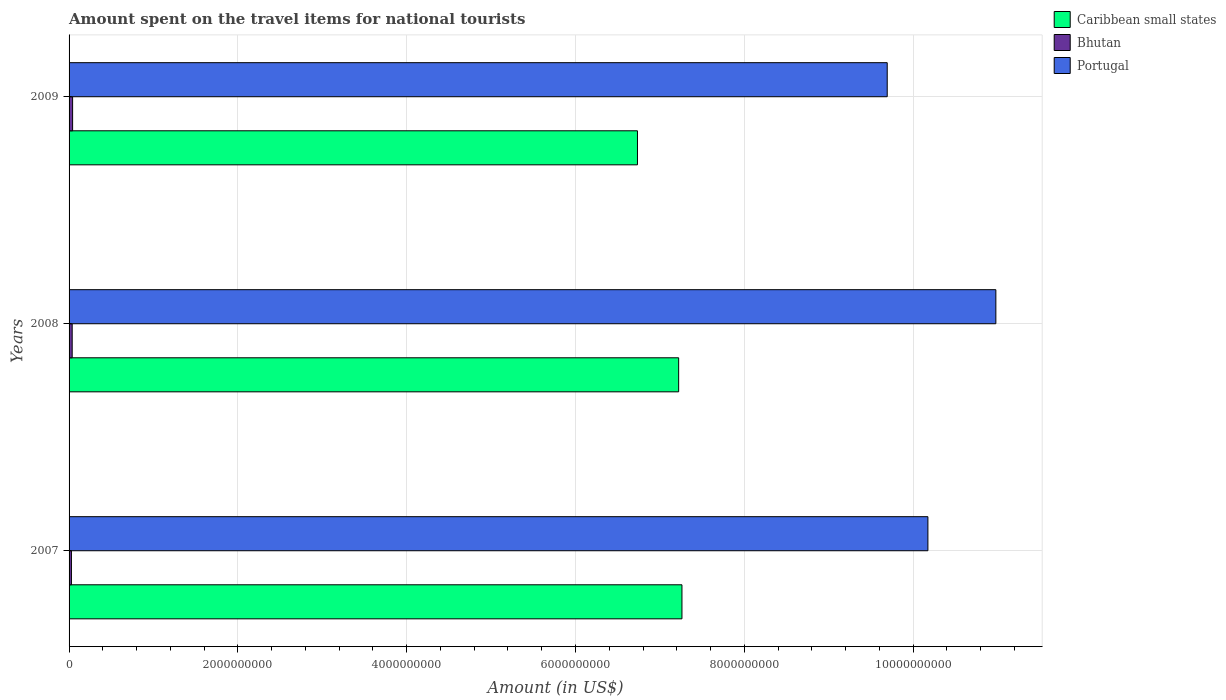How many groups of bars are there?
Your answer should be compact. 3. What is the label of the 1st group of bars from the top?
Provide a succinct answer. 2009. What is the amount spent on the travel items for national tourists in Portugal in 2009?
Offer a very short reply. 9.69e+09. Across all years, what is the maximum amount spent on the travel items for national tourists in Caribbean small states?
Give a very brief answer. 7.26e+09. Across all years, what is the minimum amount spent on the travel items for national tourists in Caribbean small states?
Your response must be concise. 6.73e+09. What is the total amount spent on the travel items for national tourists in Portugal in the graph?
Give a very brief answer. 3.08e+1. What is the difference between the amount spent on the travel items for national tourists in Portugal in 2007 and that in 2009?
Make the answer very short. 4.82e+08. What is the difference between the amount spent on the travel items for national tourists in Portugal in 2009 and the amount spent on the travel items for national tourists in Caribbean small states in 2007?
Provide a succinct answer. 2.43e+09. What is the average amount spent on the travel items for national tourists in Caribbean small states per year?
Offer a terse response. 7.07e+09. In the year 2008, what is the difference between the amount spent on the travel items for national tourists in Caribbean small states and amount spent on the travel items for national tourists in Bhutan?
Keep it short and to the point. 7.18e+09. In how many years, is the amount spent on the travel items for national tourists in Caribbean small states greater than 7600000000 US$?
Ensure brevity in your answer.  0. What is the ratio of the amount spent on the travel items for national tourists in Caribbean small states in 2008 to that in 2009?
Make the answer very short. 1.07. Is the amount spent on the travel items for national tourists in Caribbean small states in 2008 less than that in 2009?
Keep it short and to the point. No. What is the difference between the highest and the second highest amount spent on the travel items for national tourists in Portugal?
Provide a short and direct response. 8.05e+08. What is the difference between the highest and the lowest amount spent on the travel items for national tourists in Portugal?
Give a very brief answer. 1.29e+09. In how many years, is the amount spent on the travel items for national tourists in Bhutan greater than the average amount spent on the travel items for national tourists in Bhutan taken over all years?
Provide a succinct answer. 2. What does the 3rd bar from the top in 2007 represents?
Ensure brevity in your answer.  Caribbean small states. What does the 2nd bar from the bottom in 2008 represents?
Your answer should be compact. Bhutan. How many bars are there?
Keep it short and to the point. 9. How many years are there in the graph?
Provide a short and direct response. 3. Are the values on the major ticks of X-axis written in scientific E-notation?
Provide a succinct answer. No. What is the title of the graph?
Your answer should be compact. Amount spent on the travel items for national tourists. Does "Ecuador" appear as one of the legend labels in the graph?
Your answer should be very brief. No. What is the label or title of the X-axis?
Your answer should be very brief. Amount (in US$). What is the label or title of the Y-axis?
Your answer should be compact. Years. What is the Amount (in US$) in Caribbean small states in 2007?
Your answer should be very brief. 7.26e+09. What is the Amount (in US$) in Bhutan in 2007?
Your response must be concise. 2.80e+07. What is the Amount (in US$) in Portugal in 2007?
Give a very brief answer. 1.02e+1. What is the Amount (in US$) in Caribbean small states in 2008?
Offer a very short reply. 7.22e+09. What is the Amount (in US$) in Bhutan in 2008?
Ensure brevity in your answer.  3.70e+07. What is the Amount (in US$) of Portugal in 2008?
Provide a short and direct response. 1.10e+1. What is the Amount (in US$) in Caribbean small states in 2009?
Your response must be concise. 6.73e+09. What is the Amount (in US$) of Bhutan in 2009?
Offer a terse response. 4.20e+07. What is the Amount (in US$) in Portugal in 2009?
Provide a short and direct response. 9.69e+09. Across all years, what is the maximum Amount (in US$) in Caribbean small states?
Make the answer very short. 7.26e+09. Across all years, what is the maximum Amount (in US$) of Bhutan?
Offer a terse response. 4.20e+07. Across all years, what is the maximum Amount (in US$) in Portugal?
Offer a terse response. 1.10e+1. Across all years, what is the minimum Amount (in US$) of Caribbean small states?
Offer a terse response. 6.73e+09. Across all years, what is the minimum Amount (in US$) of Bhutan?
Provide a succinct answer. 2.80e+07. Across all years, what is the minimum Amount (in US$) of Portugal?
Keep it short and to the point. 9.69e+09. What is the total Amount (in US$) of Caribbean small states in the graph?
Your response must be concise. 2.12e+1. What is the total Amount (in US$) of Bhutan in the graph?
Keep it short and to the point. 1.07e+08. What is the total Amount (in US$) in Portugal in the graph?
Give a very brief answer. 3.08e+1. What is the difference between the Amount (in US$) of Caribbean small states in 2007 and that in 2008?
Your response must be concise. 3.90e+07. What is the difference between the Amount (in US$) of Bhutan in 2007 and that in 2008?
Your answer should be compact. -9.00e+06. What is the difference between the Amount (in US$) of Portugal in 2007 and that in 2008?
Your answer should be compact. -8.05e+08. What is the difference between the Amount (in US$) of Caribbean small states in 2007 and that in 2009?
Offer a very short reply. 5.27e+08. What is the difference between the Amount (in US$) of Bhutan in 2007 and that in 2009?
Offer a terse response. -1.40e+07. What is the difference between the Amount (in US$) in Portugal in 2007 and that in 2009?
Offer a very short reply. 4.82e+08. What is the difference between the Amount (in US$) of Caribbean small states in 2008 and that in 2009?
Keep it short and to the point. 4.88e+08. What is the difference between the Amount (in US$) of Bhutan in 2008 and that in 2009?
Your answer should be very brief. -5.00e+06. What is the difference between the Amount (in US$) of Portugal in 2008 and that in 2009?
Give a very brief answer. 1.29e+09. What is the difference between the Amount (in US$) in Caribbean small states in 2007 and the Amount (in US$) in Bhutan in 2008?
Your answer should be compact. 7.22e+09. What is the difference between the Amount (in US$) in Caribbean small states in 2007 and the Amount (in US$) in Portugal in 2008?
Your answer should be compact. -3.72e+09. What is the difference between the Amount (in US$) in Bhutan in 2007 and the Amount (in US$) in Portugal in 2008?
Provide a short and direct response. -1.10e+1. What is the difference between the Amount (in US$) of Caribbean small states in 2007 and the Amount (in US$) of Bhutan in 2009?
Ensure brevity in your answer.  7.22e+09. What is the difference between the Amount (in US$) in Caribbean small states in 2007 and the Amount (in US$) in Portugal in 2009?
Your response must be concise. -2.43e+09. What is the difference between the Amount (in US$) in Bhutan in 2007 and the Amount (in US$) in Portugal in 2009?
Offer a very short reply. -9.66e+09. What is the difference between the Amount (in US$) of Caribbean small states in 2008 and the Amount (in US$) of Bhutan in 2009?
Keep it short and to the point. 7.18e+09. What is the difference between the Amount (in US$) in Caribbean small states in 2008 and the Amount (in US$) in Portugal in 2009?
Provide a succinct answer. -2.47e+09. What is the difference between the Amount (in US$) in Bhutan in 2008 and the Amount (in US$) in Portugal in 2009?
Your response must be concise. -9.66e+09. What is the average Amount (in US$) of Caribbean small states per year?
Your response must be concise. 7.07e+09. What is the average Amount (in US$) in Bhutan per year?
Your answer should be very brief. 3.57e+07. What is the average Amount (in US$) of Portugal per year?
Keep it short and to the point. 1.03e+1. In the year 2007, what is the difference between the Amount (in US$) in Caribbean small states and Amount (in US$) in Bhutan?
Ensure brevity in your answer.  7.23e+09. In the year 2007, what is the difference between the Amount (in US$) of Caribbean small states and Amount (in US$) of Portugal?
Offer a terse response. -2.91e+09. In the year 2007, what is the difference between the Amount (in US$) of Bhutan and Amount (in US$) of Portugal?
Provide a short and direct response. -1.01e+1. In the year 2008, what is the difference between the Amount (in US$) in Caribbean small states and Amount (in US$) in Bhutan?
Make the answer very short. 7.18e+09. In the year 2008, what is the difference between the Amount (in US$) in Caribbean small states and Amount (in US$) in Portugal?
Your response must be concise. -3.76e+09. In the year 2008, what is the difference between the Amount (in US$) of Bhutan and Amount (in US$) of Portugal?
Provide a succinct answer. -1.09e+1. In the year 2009, what is the difference between the Amount (in US$) in Caribbean small states and Amount (in US$) in Bhutan?
Provide a succinct answer. 6.69e+09. In the year 2009, what is the difference between the Amount (in US$) of Caribbean small states and Amount (in US$) of Portugal?
Provide a short and direct response. -2.96e+09. In the year 2009, what is the difference between the Amount (in US$) of Bhutan and Amount (in US$) of Portugal?
Provide a short and direct response. -9.65e+09. What is the ratio of the Amount (in US$) of Caribbean small states in 2007 to that in 2008?
Provide a short and direct response. 1.01. What is the ratio of the Amount (in US$) of Bhutan in 2007 to that in 2008?
Provide a short and direct response. 0.76. What is the ratio of the Amount (in US$) in Portugal in 2007 to that in 2008?
Ensure brevity in your answer.  0.93. What is the ratio of the Amount (in US$) in Caribbean small states in 2007 to that in 2009?
Give a very brief answer. 1.08. What is the ratio of the Amount (in US$) in Portugal in 2007 to that in 2009?
Make the answer very short. 1.05. What is the ratio of the Amount (in US$) in Caribbean small states in 2008 to that in 2009?
Make the answer very short. 1.07. What is the ratio of the Amount (in US$) of Bhutan in 2008 to that in 2009?
Your answer should be very brief. 0.88. What is the ratio of the Amount (in US$) of Portugal in 2008 to that in 2009?
Your answer should be very brief. 1.13. What is the difference between the highest and the second highest Amount (in US$) of Caribbean small states?
Ensure brevity in your answer.  3.90e+07. What is the difference between the highest and the second highest Amount (in US$) in Portugal?
Provide a succinct answer. 8.05e+08. What is the difference between the highest and the lowest Amount (in US$) of Caribbean small states?
Your answer should be very brief. 5.27e+08. What is the difference between the highest and the lowest Amount (in US$) in Bhutan?
Offer a terse response. 1.40e+07. What is the difference between the highest and the lowest Amount (in US$) of Portugal?
Make the answer very short. 1.29e+09. 